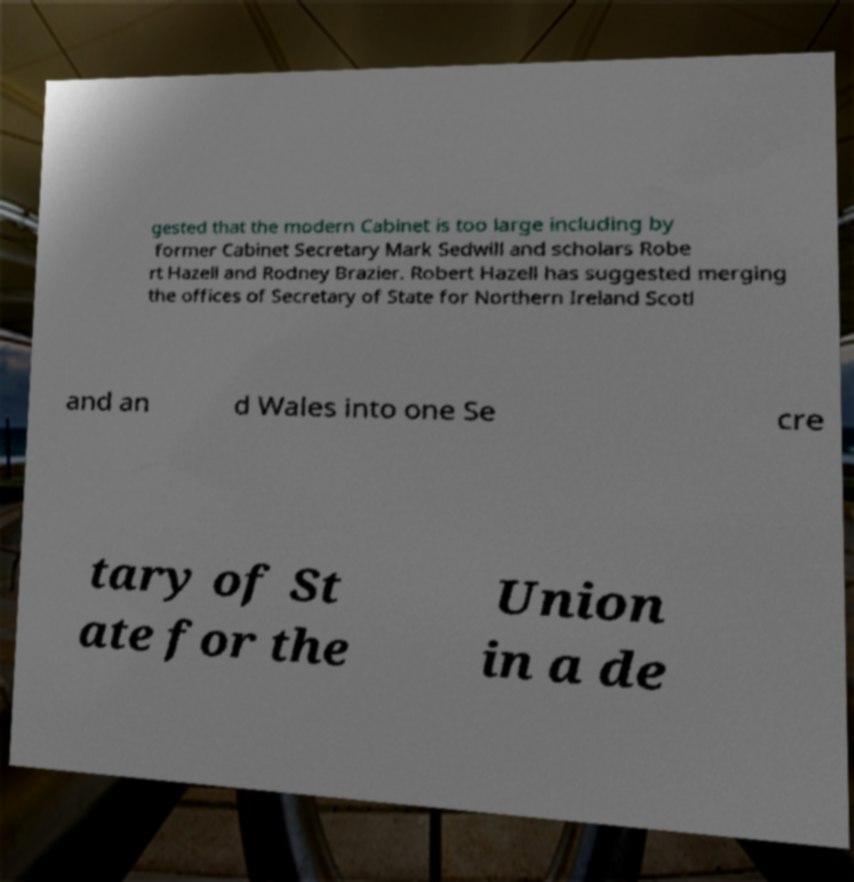There's text embedded in this image that I need extracted. Can you transcribe it verbatim? gested that the modern Cabinet is too large including by former Cabinet Secretary Mark Sedwill and scholars Robe rt Hazell and Rodney Brazier. Robert Hazell has suggested merging the offices of Secretary of State for Northern Ireland Scotl and an d Wales into one Se cre tary of St ate for the Union in a de 